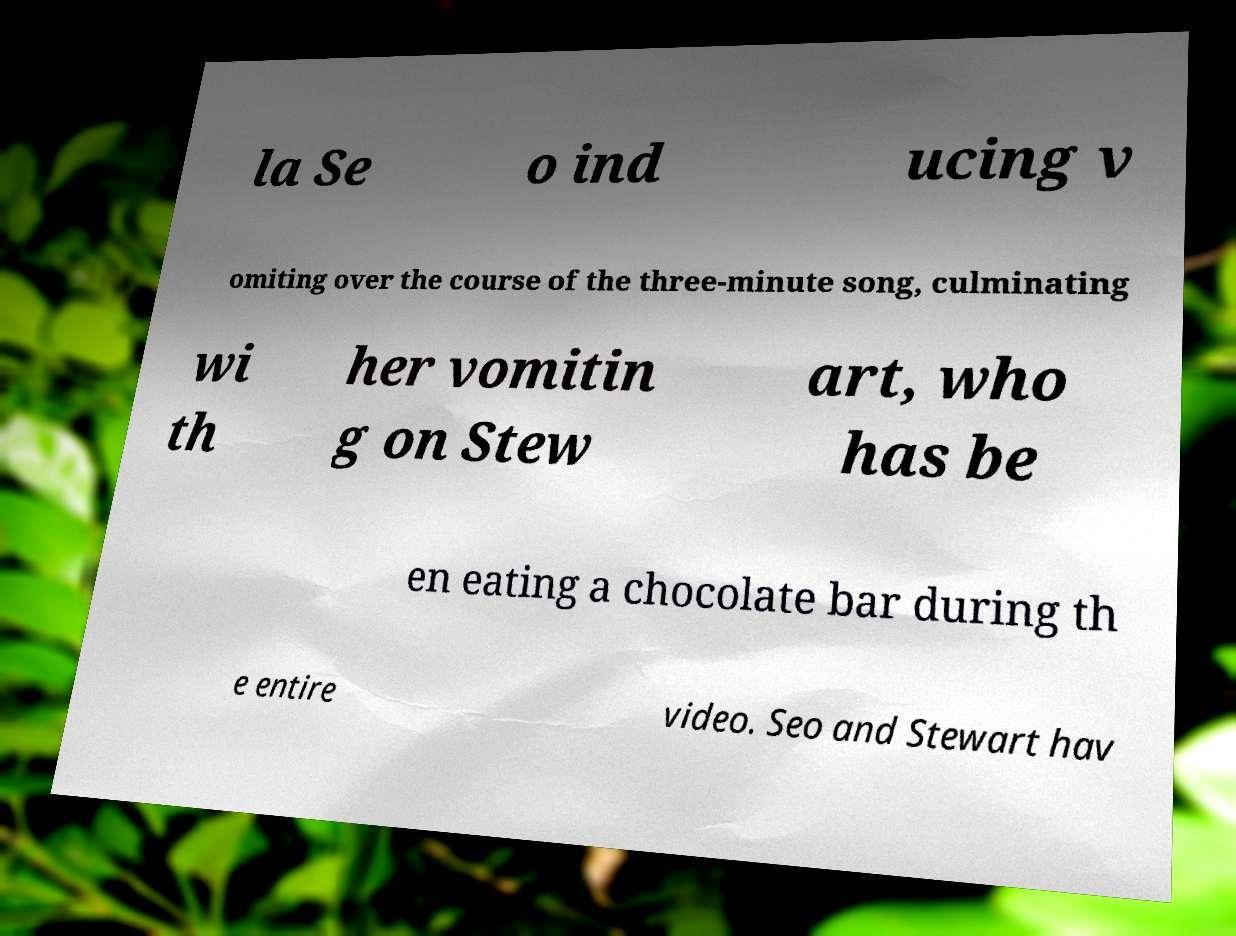What messages or text are displayed in this image? I need them in a readable, typed format. la Se o ind ucing v omiting over the course of the three-minute song, culminating wi th her vomitin g on Stew art, who has be en eating a chocolate bar during th e entire video. Seo and Stewart hav 